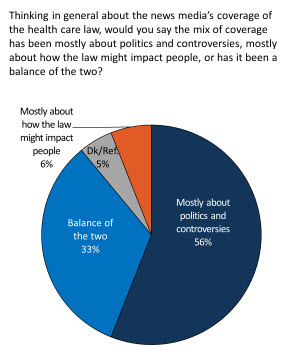Outline some significant characteristics in this image. There are four colors displayed in the pie chart. To find the difference between the sum total of politics and controversies and the Mostly category, we must first add up all the three least value of the Politics and Controversies categories. 